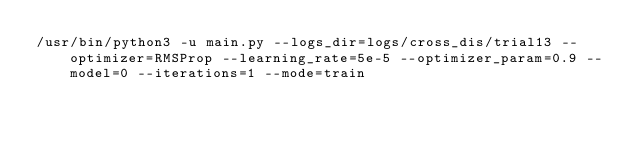<code> <loc_0><loc_0><loc_500><loc_500><_Bash_>/usr/bin/python3 -u main.py --logs_dir=logs/cross_dis/trial13 --optimizer=RMSProp --learning_rate=5e-5 --optimizer_param=0.9 --model=0 --iterations=1 --mode=train

</code> 